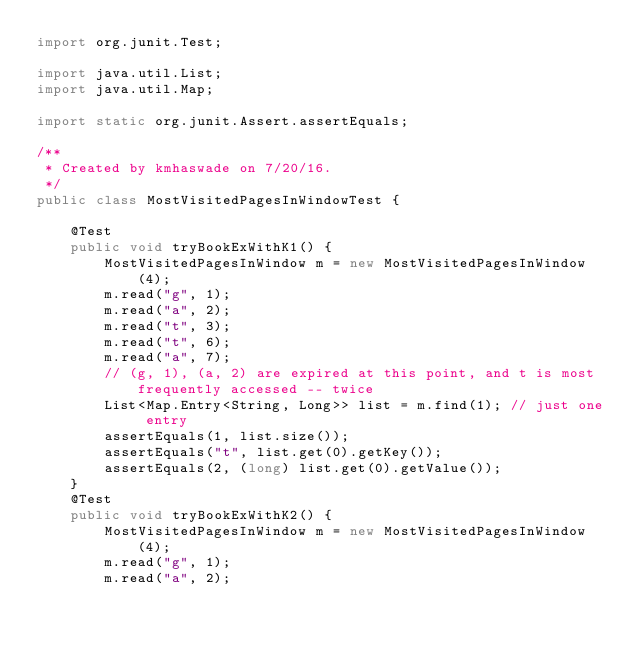Convert code to text. <code><loc_0><loc_0><loc_500><loc_500><_Java_>import org.junit.Test;

import java.util.List;
import java.util.Map;

import static org.junit.Assert.assertEquals;

/**
 * Created by kmhaswade on 7/20/16.
 */
public class MostVisitedPagesInWindowTest {

    @Test
    public void tryBookExWithK1() {
        MostVisitedPagesInWindow m = new MostVisitedPagesInWindow(4);
        m.read("g", 1);
        m.read("a", 2);
        m.read("t", 3);
        m.read("t", 6);
        m.read("a", 7);
        // (g, 1), (a, 2) are expired at this point, and t is most frequently accessed -- twice
        List<Map.Entry<String, Long>> list = m.find(1); // just one entry
        assertEquals(1, list.size());
        assertEquals("t", list.get(0).getKey());
        assertEquals(2, (long) list.get(0).getValue());
    }
    @Test
    public void tryBookExWithK2() {
        MostVisitedPagesInWindow m = new MostVisitedPagesInWindow(4);
        m.read("g", 1);
        m.read("a", 2);</code> 